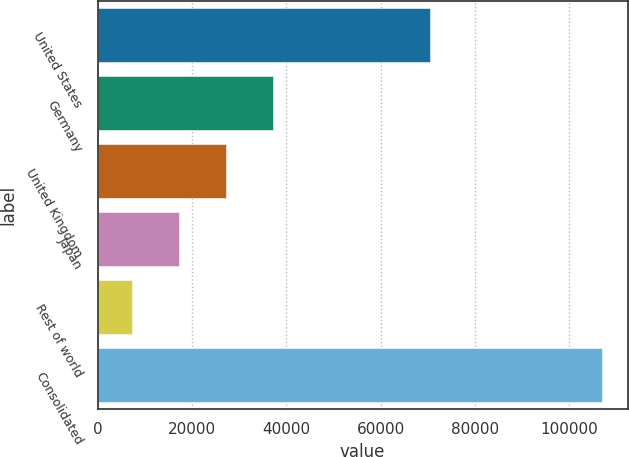Convert chart. <chart><loc_0><loc_0><loc_500><loc_500><bar_chart><fcel>United States<fcel>Germany<fcel>United Kingdom<fcel>Japan<fcel>Rest of world<fcel>Consolidated<nl><fcel>70537<fcel>37251<fcel>27286<fcel>17321<fcel>7356<fcel>107006<nl></chart> 